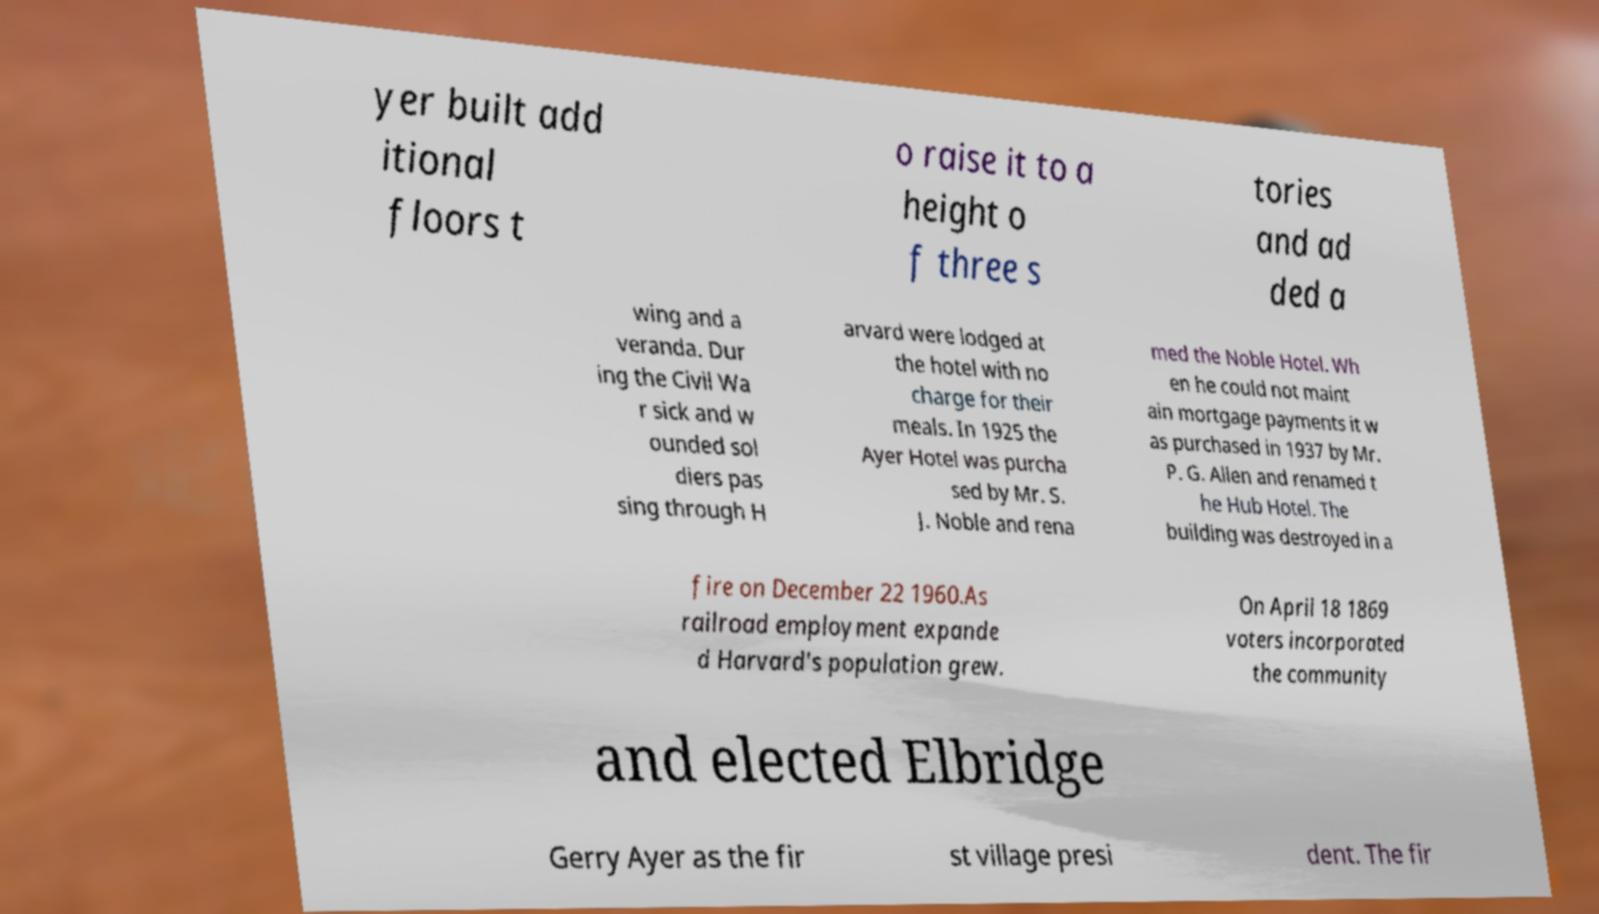Can you read and provide the text displayed in the image?This photo seems to have some interesting text. Can you extract and type it out for me? yer built add itional floors t o raise it to a height o f three s tories and ad ded a wing and a veranda. Dur ing the Civil Wa r sick and w ounded sol diers pas sing through H arvard were lodged at the hotel with no charge for their meals. In 1925 the Ayer Hotel was purcha sed by Mr. S. J. Noble and rena med the Noble Hotel. Wh en he could not maint ain mortgage payments it w as purchased in 1937 by Mr. P. G. Allen and renamed t he Hub Hotel. The building was destroyed in a fire on December 22 1960.As railroad employment expande d Harvard's population grew. On April 18 1869 voters incorporated the community and elected Elbridge Gerry Ayer as the fir st village presi dent. The fir 